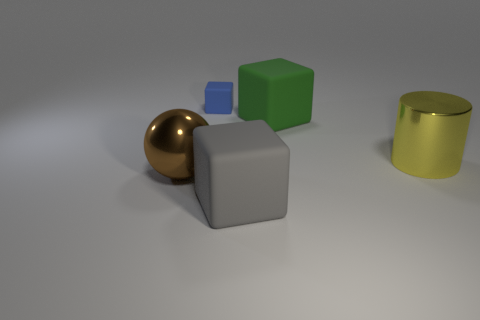What objects can be seen in the image and how are they positioned in relation to each other? The image displays several geometric shapes with varying materials and textures, meticulously arranged on a flat surface. A reflective brown sphere, a matte gray cube, a translucent blue cube, a solid green cube, and a reflective gold cylinder are positioned from left to right in a roughly linear configuration across the middle of the frame. Can you describe the lighting in the scene? The scene is softly lit with diffused lighting that seems to come from above, casting gentle shadows beneath each of the objects. The lighting accentuates the textures and materials of the objects, highlighting their shapes and allowing their colors to be distinctly perceived. 